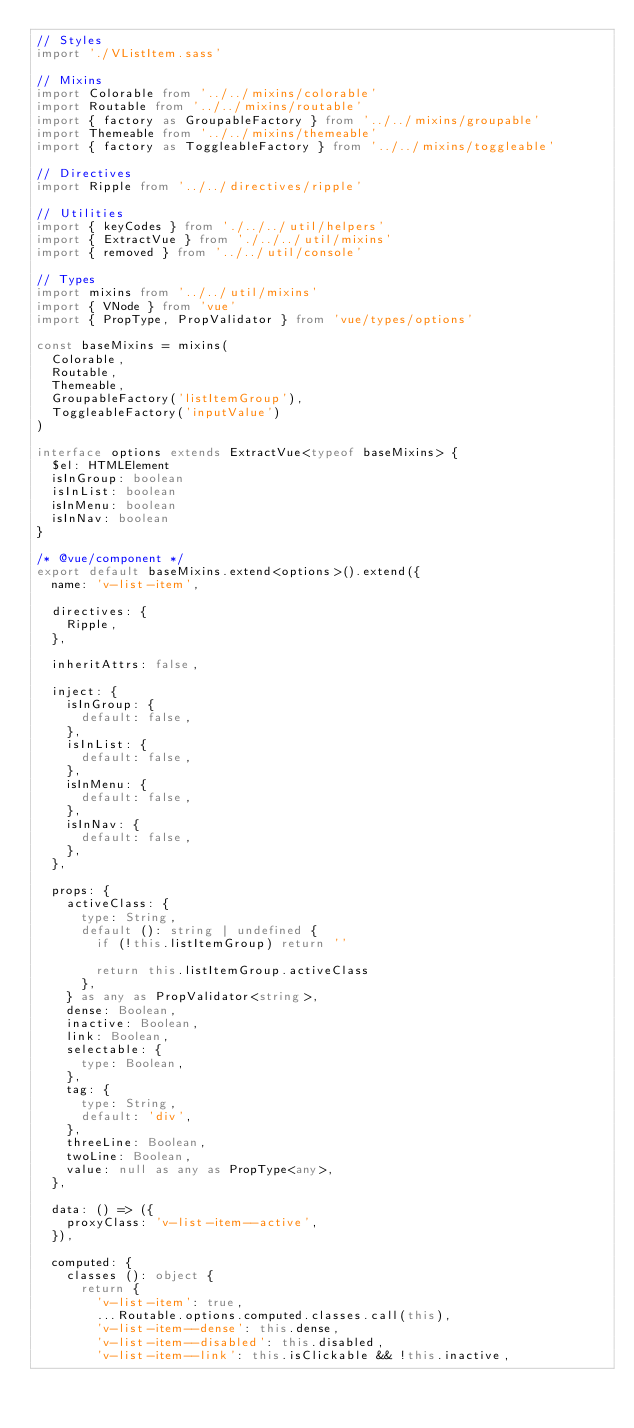Convert code to text. <code><loc_0><loc_0><loc_500><loc_500><_TypeScript_>// Styles
import './VListItem.sass'

// Mixins
import Colorable from '../../mixins/colorable'
import Routable from '../../mixins/routable'
import { factory as GroupableFactory } from '../../mixins/groupable'
import Themeable from '../../mixins/themeable'
import { factory as ToggleableFactory } from '../../mixins/toggleable'

// Directives
import Ripple from '../../directives/ripple'

// Utilities
import { keyCodes } from './../../util/helpers'
import { ExtractVue } from './../../util/mixins'
import { removed } from '../../util/console'

// Types
import mixins from '../../util/mixins'
import { VNode } from 'vue'
import { PropType, PropValidator } from 'vue/types/options'

const baseMixins = mixins(
  Colorable,
  Routable,
  Themeable,
  GroupableFactory('listItemGroup'),
  ToggleableFactory('inputValue')
)

interface options extends ExtractVue<typeof baseMixins> {
  $el: HTMLElement
  isInGroup: boolean
  isInList: boolean
  isInMenu: boolean
  isInNav: boolean
}

/* @vue/component */
export default baseMixins.extend<options>().extend({
  name: 'v-list-item',

  directives: {
    Ripple,
  },

  inheritAttrs: false,

  inject: {
    isInGroup: {
      default: false,
    },
    isInList: {
      default: false,
    },
    isInMenu: {
      default: false,
    },
    isInNav: {
      default: false,
    },
  },

  props: {
    activeClass: {
      type: String,
      default (): string | undefined {
        if (!this.listItemGroup) return ''

        return this.listItemGroup.activeClass
      },
    } as any as PropValidator<string>,
    dense: Boolean,
    inactive: Boolean,
    link: Boolean,
    selectable: {
      type: Boolean,
    },
    tag: {
      type: String,
      default: 'div',
    },
    threeLine: Boolean,
    twoLine: Boolean,
    value: null as any as PropType<any>,
  },

  data: () => ({
    proxyClass: 'v-list-item--active',
  }),

  computed: {
    classes (): object {
      return {
        'v-list-item': true,
        ...Routable.options.computed.classes.call(this),
        'v-list-item--dense': this.dense,
        'v-list-item--disabled': this.disabled,
        'v-list-item--link': this.isClickable && !this.inactive,</code> 